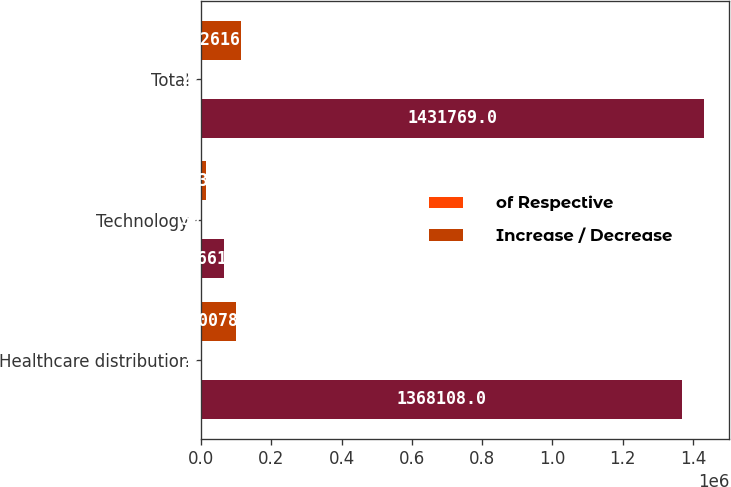Convert chart to OTSL. <chart><loc_0><loc_0><loc_500><loc_500><stacked_bar_chart><ecel><fcel>Healthcare distribution<fcel>Technology<fcel>Total<nl><fcel>nan<fcel>1.36811e+06<fcel>63661<fcel>1.43177e+06<nl><fcel>of Respective<fcel>22<fcel>39<fcel>22.4<nl><fcel>Increase / Decrease<fcel>100078<fcel>12538<fcel>112616<nl></chart> 